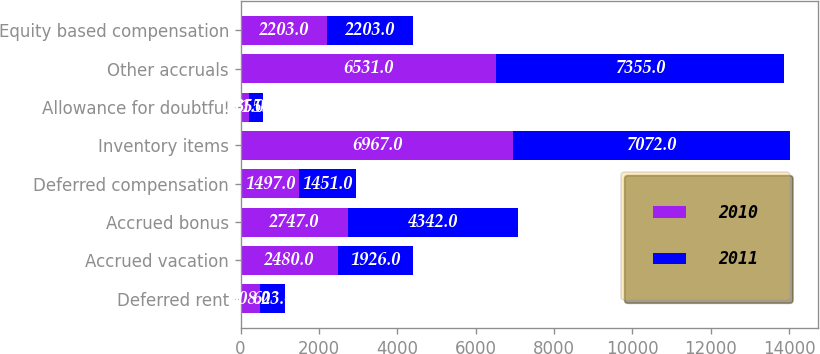Convert chart. <chart><loc_0><loc_0><loc_500><loc_500><stacked_bar_chart><ecel><fcel>Deferred rent<fcel>Accrued vacation<fcel>Accrued bonus<fcel>Deferred compensation<fcel>Inventory items<fcel>Allowance for doubtful<fcel>Other accruals<fcel>Equity based compensation<nl><fcel>2010<fcel>508<fcel>2480<fcel>2747<fcel>1497<fcel>6967<fcel>211<fcel>6531<fcel>2203<nl><fcel>2011<fcel>623<fcel>1926<fcel>4342<fcel>1451<fcel>7072<fcel>355<fcel>7355<fcel>2203<nl></chart> 